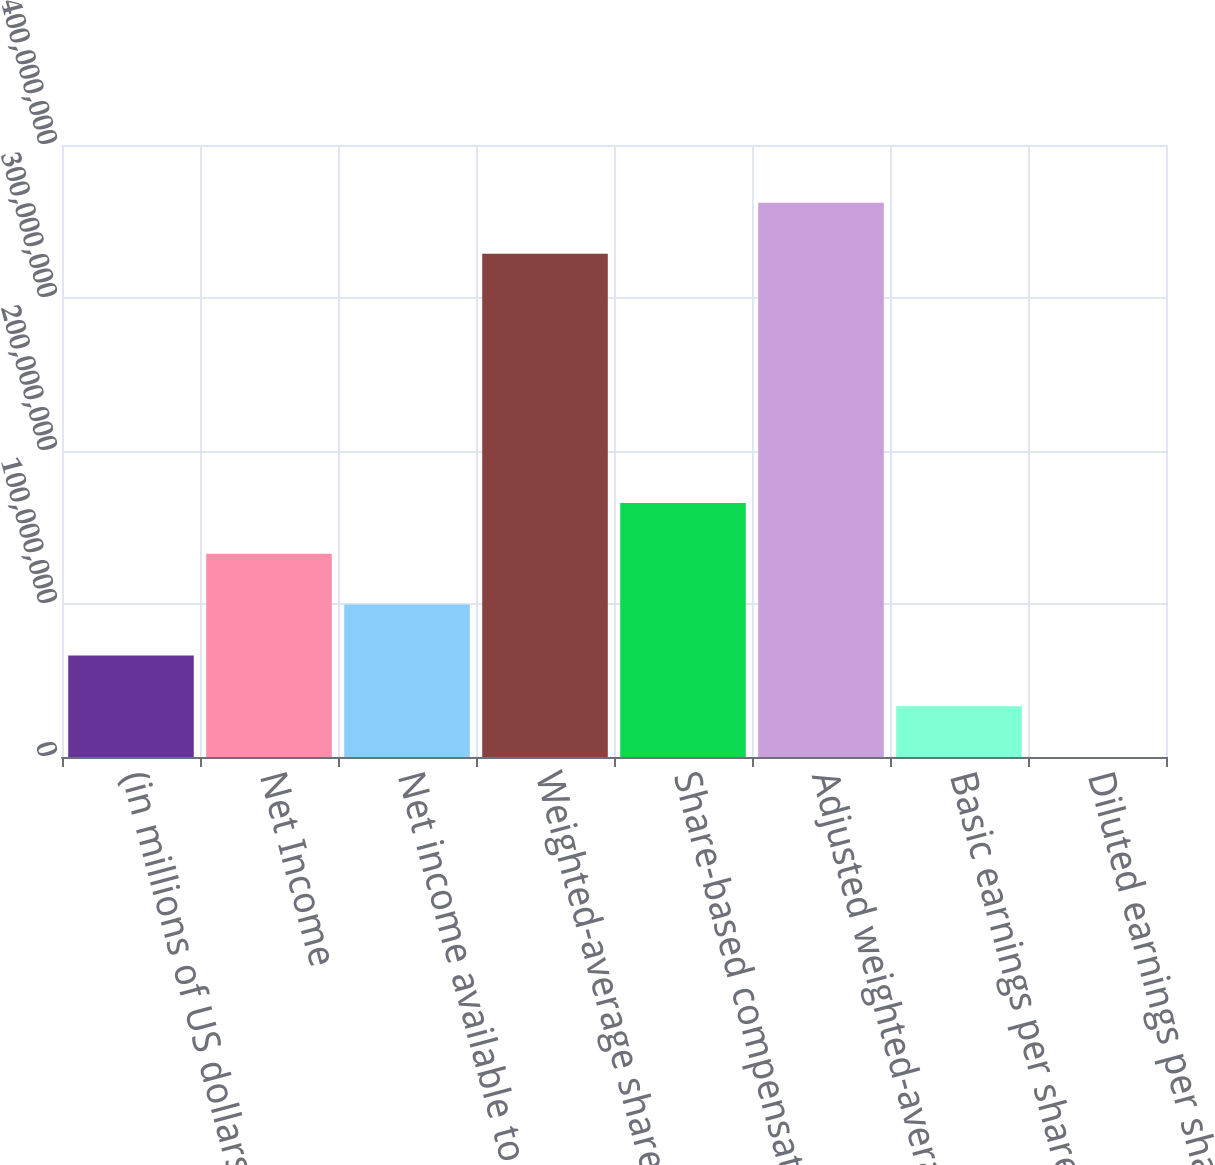<chart> <loc_0><loc_0><loc_500><loc_500><bar_chart><fcel>(in millions of US dollars<fcel>Net Income<fcel>Net income available to<fcel>Weighted-average shares<fcel>Share-based compensation plans<fcel>Adjusted weighted-average<fcel>Basic earnings per share<fcel>Diluted earnings per share<nl><fcel>6.63978e+07<fcel>1.32796e+08<fcel>9.95967e+07<fcel>3.2899e+08<fcel>1.65995e+08<fcel>3.62189e+08<fcel>3.31989e+07<fcel>7.63<nl></chart> 